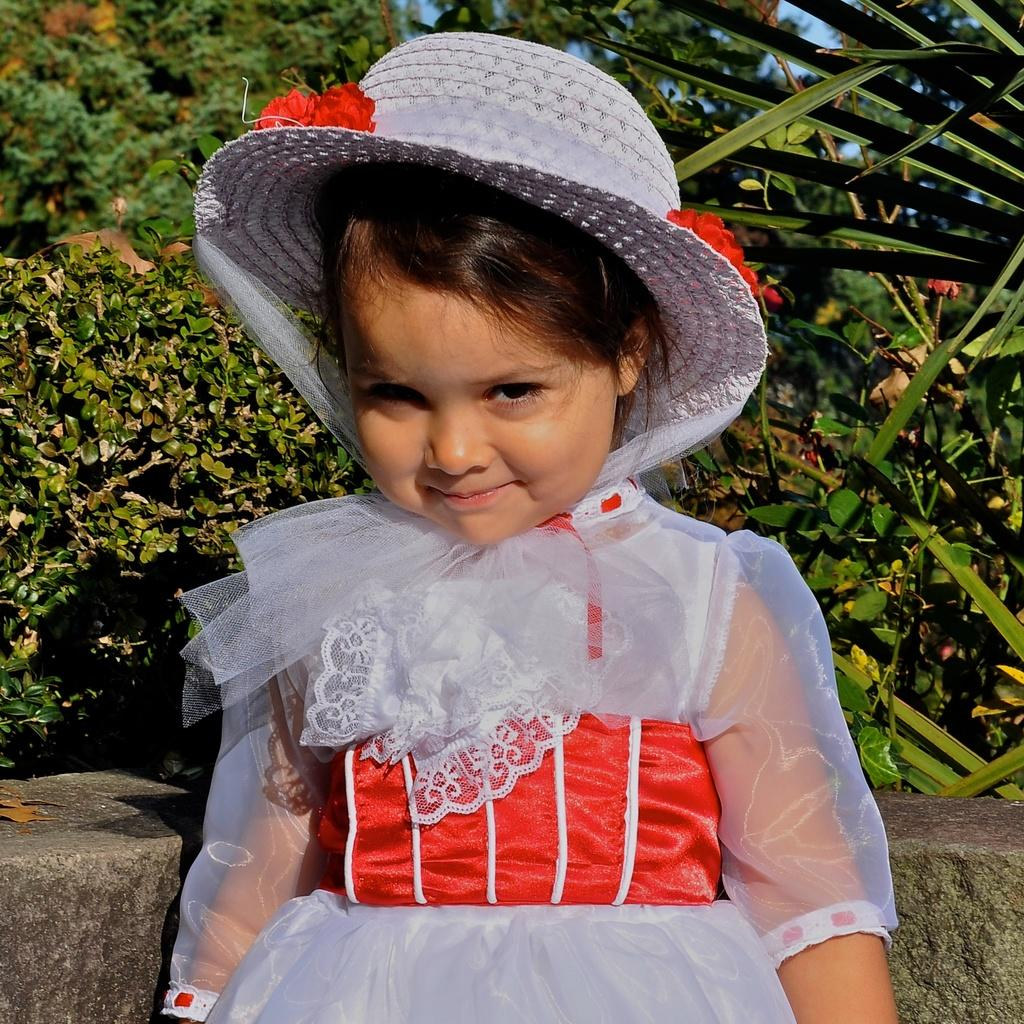What is the main subject of the image? There is a girl standing in the image. What is the girl wearing on her head? The girl is wearing a cap. What can be seen in the background of the image? There are trees visible in the background of the image. What color is the sky in the image? The sky is blue in the image. How many rings does the girl have on her fingers in the image? There is no mention of rings in the image, so we cannot determine the number of rings the girl is wearing. What type of guitar is the girl playing in the image? There is no guitar present in the image, so we cannot describe the type of guitar the girl might be playing. 